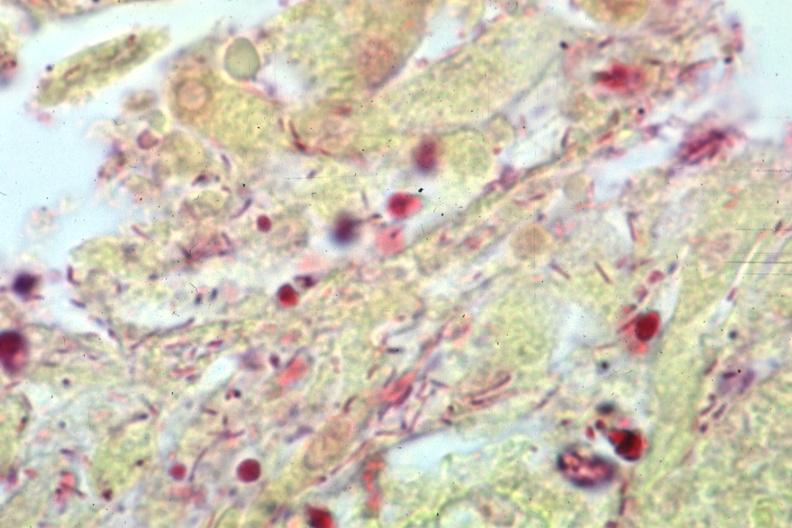what does this image show?
Answer the question using a single word or phrase. Gram stain gram negative bacteria 